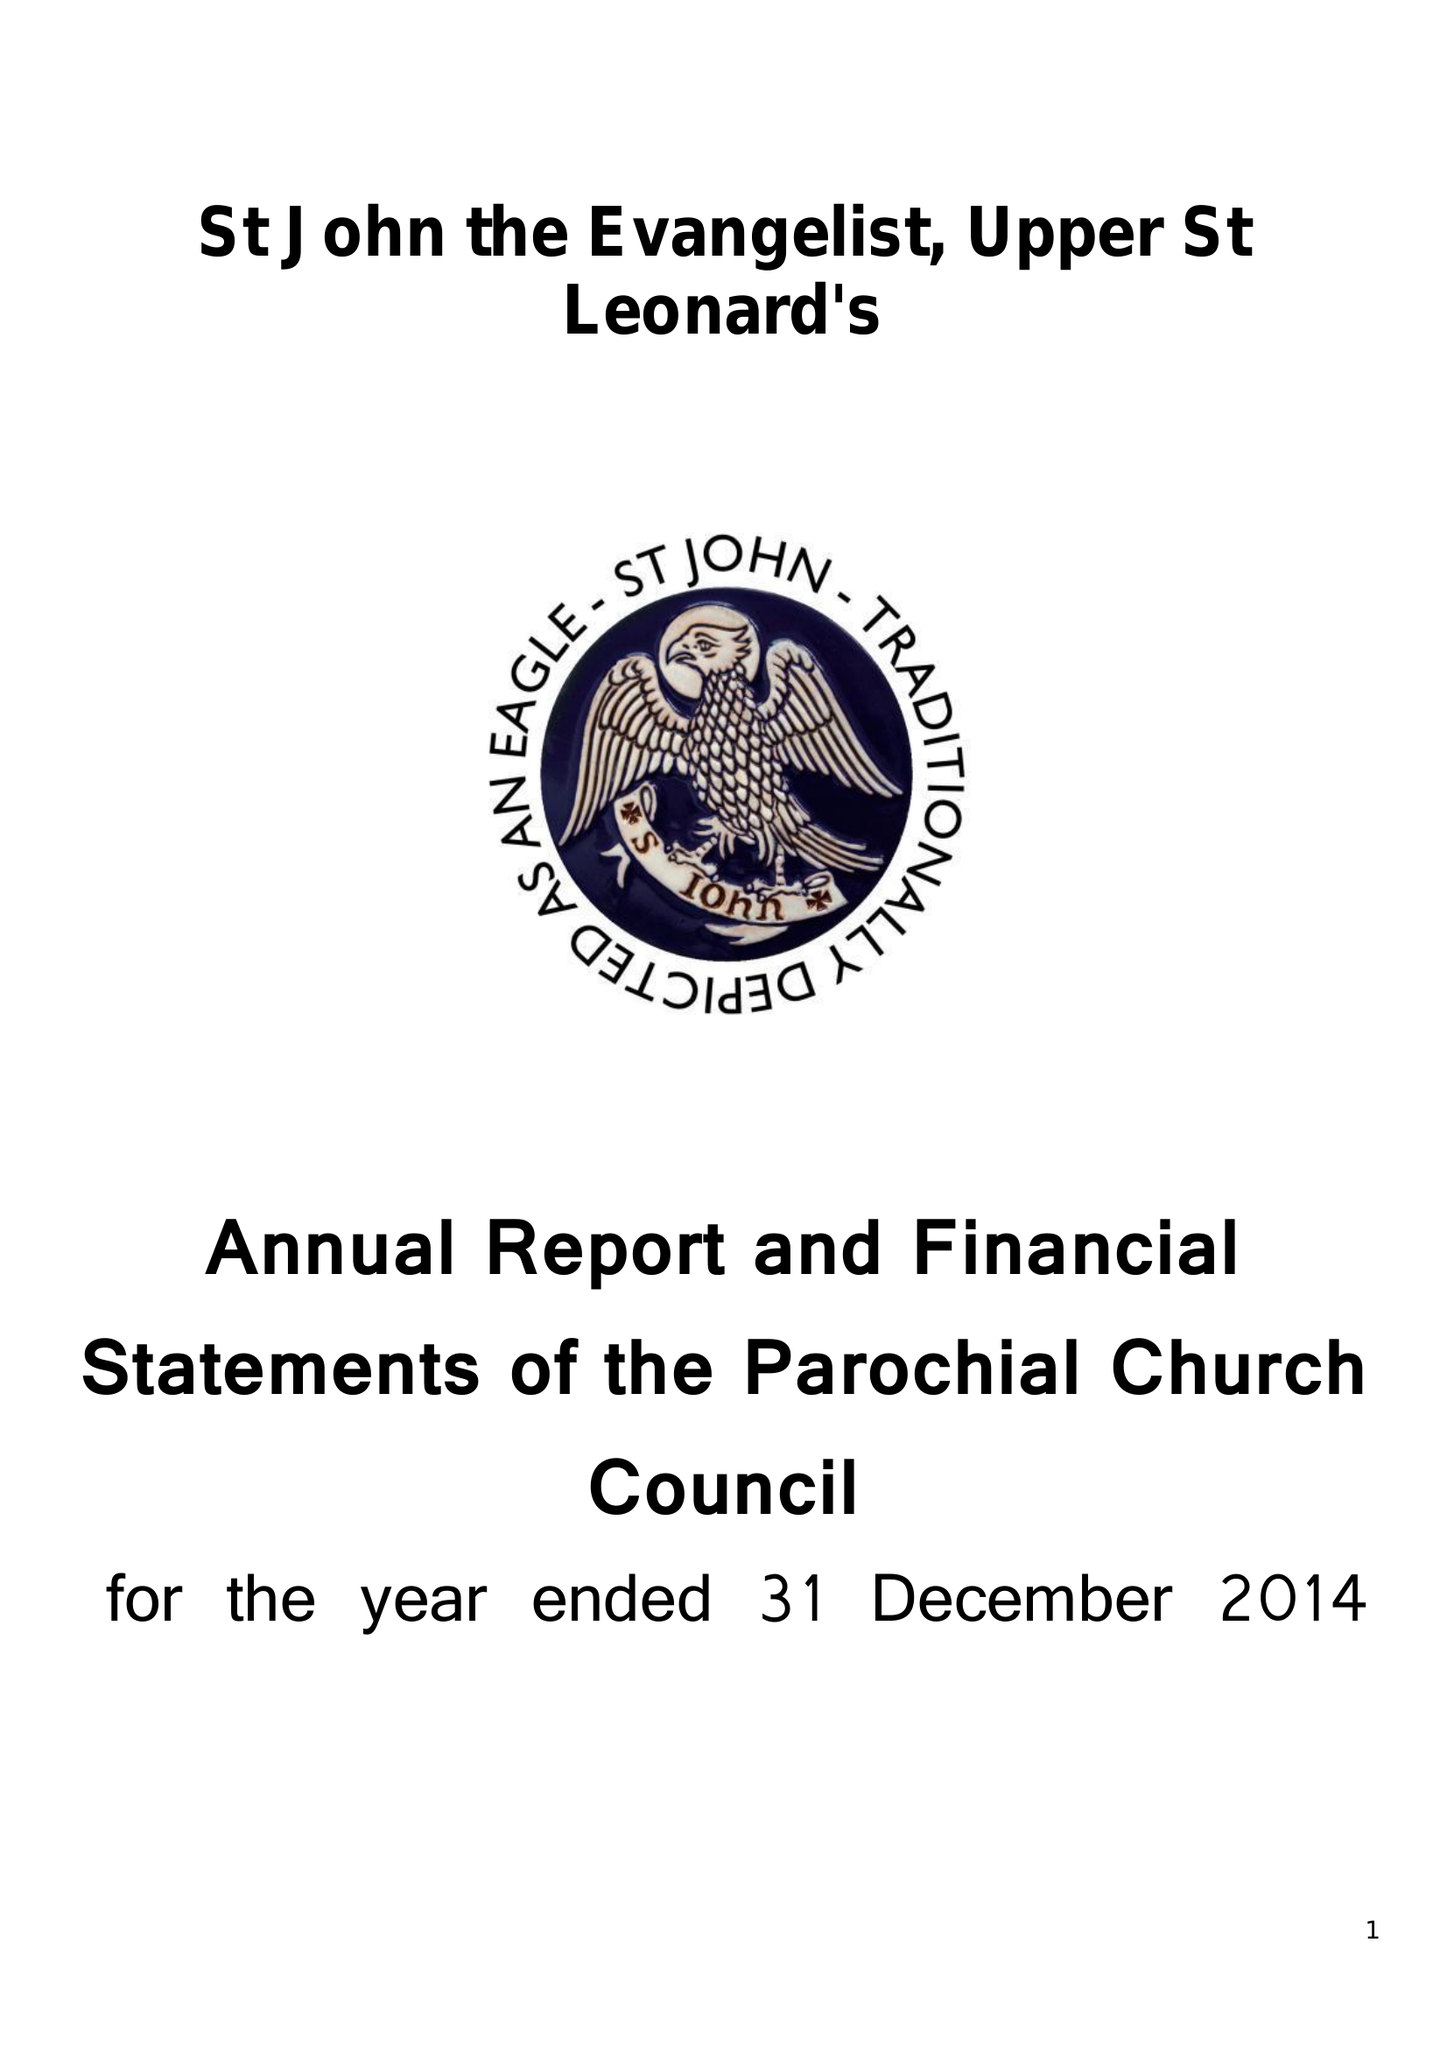What is the value for the charity_number?
Answer the question using a single word or phrase. 1132339 